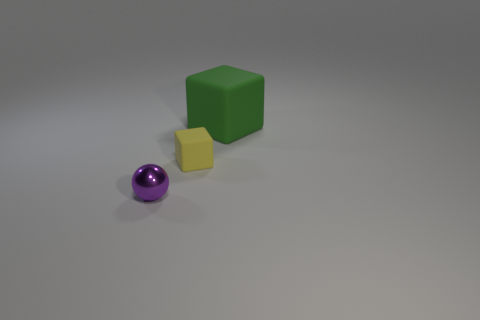Is there any other thing that has the same size as the green object?
Your answer should be compact. No. What is the size of the matte thing in front of the rubber object on the right side of the small object to the right of the tiny shiny sphere?
Provide a succinct answer. Small. How many other objects are the same shape as the small metallic object?
Give a very brief answer. 0. There is a object that is both left of the big green cube and behind the small purple metal object; what color is it?
Offer a terse response. Yellow. There is a rubber cube on the right side of the tiny yellow rubber block; does it have the same color as the small sphere?
Your response must be concise. No. What number of spheres are either red shiny things or green rubber objects?
Ensure brevity in your answer.  0. There is a rubber object to the left of the big thing; what is its shape?
Your response must be concise. Cube. There is a rubber cube left of the rubber object that is behind the matte cube that is in front of the green rubber object; what color is it?
Your answer should be very brief. Yellow. Do the big cube and the small purple thing have the same material?
Make the answer very short. No. What number of yellow things are either small rubber things or large cubes?
Provide a short and direct response. 1. 